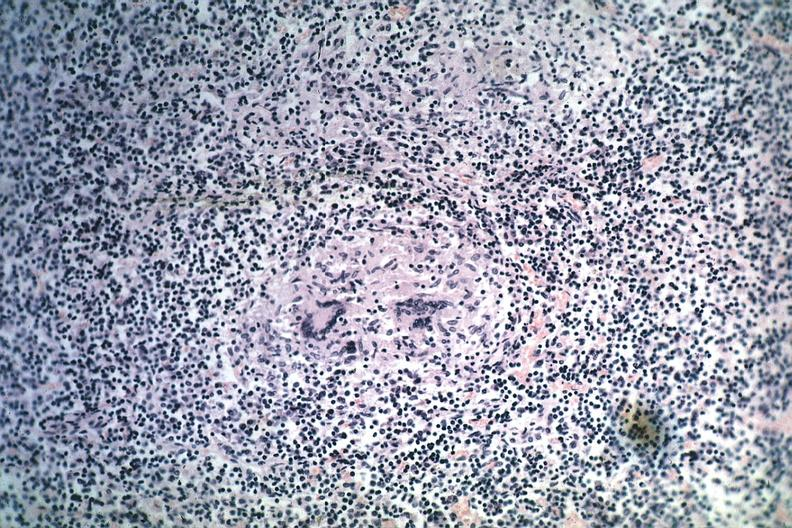how does this image show granuloma?
Answer the question using a single word or phrase. With minimal necrosis source unknown 